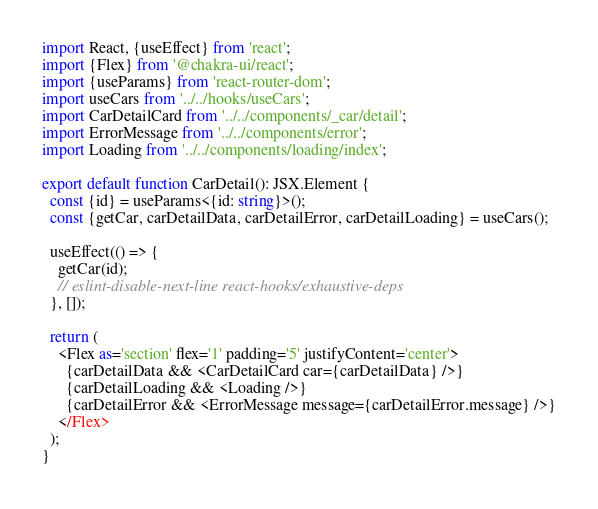<code> <loc_0><loc_0><loc_500><loc_500><_TypeScript_>import React, {useEffect} from 'react';
import {Flex} from '@chakra-ui/react';
import {useParams} from 'react-router-dom';
import useCars from '../../hooks/useCars';
import CarDetailCard from '../../components/_car/detail';
import ErrorMessage from '../../components/error';
import Loading from '../../components/loading/index';

export default function CarDetail(): JSX.Element {
  const {id} = useParams<{id: string}>();
  const {getCar, carDetailData, carDetailError, carDetailLoading} = useCars();

  useEffect(() => {
    getCar(id);
    // eslint-disable-next-line react-hooks/exhaustive-deps
  }, []);

  return (
    <Flex as='section' flex='1' padding='5' justifyContent='center'>
      {carDetailData && <CarDetailCard car={carDetailData} />}
      {carDetailLoading && <Loading />}
      {carDetailError && <ErrorMessage message={carDetailError.message} />}
    </Flex>
  );
}
</code> 